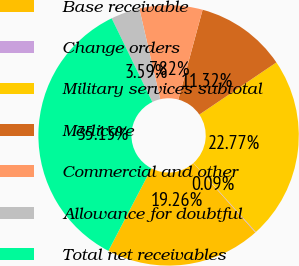Convert chart to OTSL. <chart><loc_0><loc_0><loc_500><loc_500><pie_chart><fcel>Base receivable<fcel>Change orders<fcel>Military services subtotal<fcel>Medicare<fcel>Commercial and other<fcel>Allowance for doubtful<fcel>Total net receivables<nl><fcel>19.26%<fcel>0.09%<fcel>22.77%<fcel>11.32%<fcel>7.82%<fcel>3.59%<fcel>35.15%<nl></chart> 